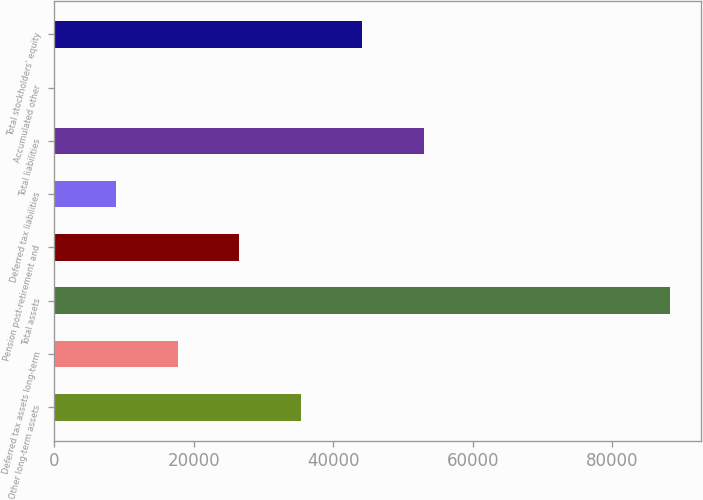<chart> <loc_0><loc_0><loc_500><loc_500><bar_chart><fcel>Other long-term assets<fcel>Deferred tax assets long-term<fcel>Total assets<fcel>Pension post-retirement and<fcel>Deferred tax liabilities<fcel>Total liabilities<fcel>Accumulated other<fcel>Total stockholders' equity<nl><fcel>35375<fcel>17733<fcel>88301<fcel>26554<fcel>8912<fcel>53017<fcel>91<fcel>44196<nl></chart> 